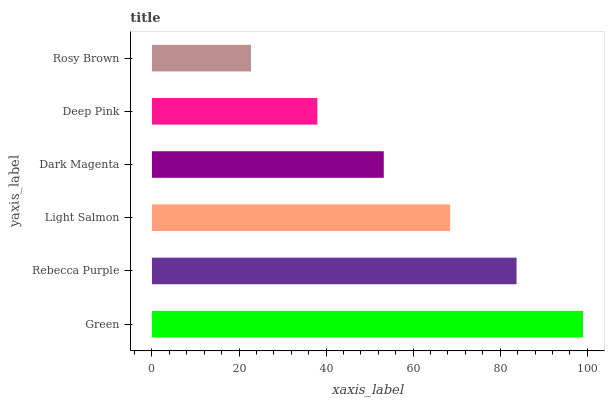Is Rosy Brown the minimum?
Answer yes or no. Yes. Is Green the maximum?
Answer yes or no. Yes. Is Rebecca Purple the minimum?
Answer yes or no. No. Is Rebecca Purple the maximum?
Answer yes or no. No. Is Green greater than Rebecca Purple?
Answer yes or no. Yes. Is Rebecca Purple less than Green?
Answer yes or no. Yes. Is Rebecca Purple greater than Green?
Answer yes or no. No. Is Green less than Rebecca Purple?
Answer yes or no. No. Is Light Salmon the high median?
Answer yes or no. Yes. Is Dark Magenta the low median?
Answer yes or no. Yes. Is Dark Magenta the high median?
Answer yes or no. No. Is Rebecca Purple the low median?
Answer yes or no. No. 